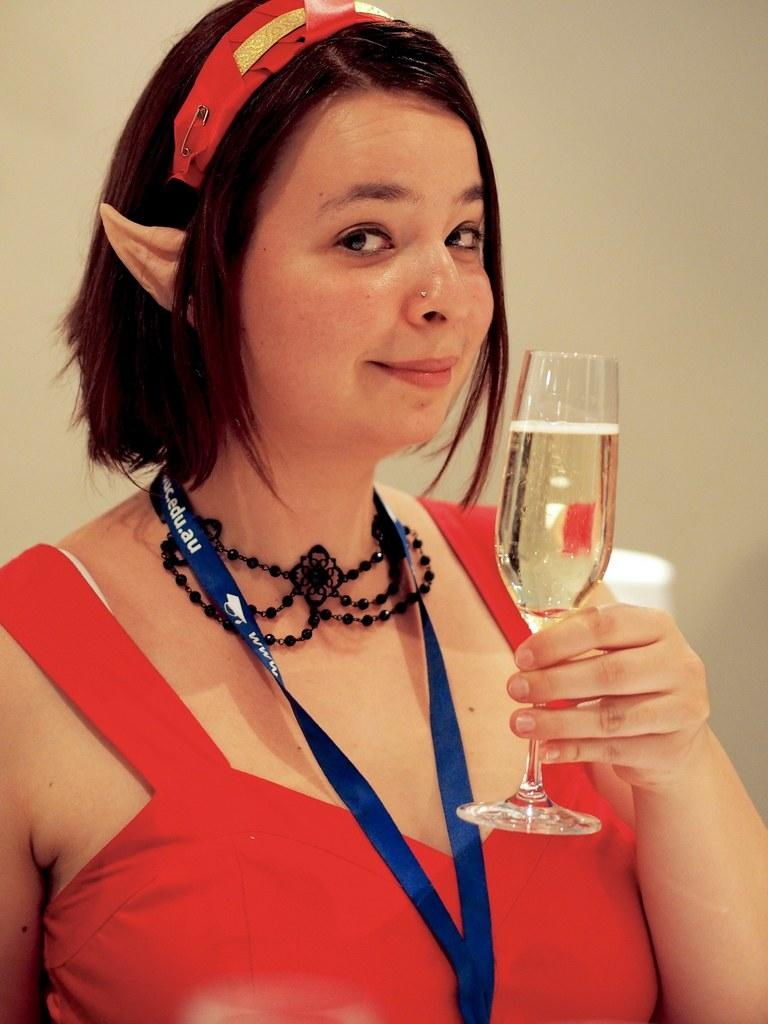Who is the main subject in the image? There is a woman in the image. What is the woman wearing? The woman is wearing a red dress. What expression does the woman have? The woman is smiling. What is the woman holding in the image? The woman is holding a glass. What type of desk can be seen in the image? There is no desk present in the image. Is the woman using a knife in the image? There is no knife present in the image. 